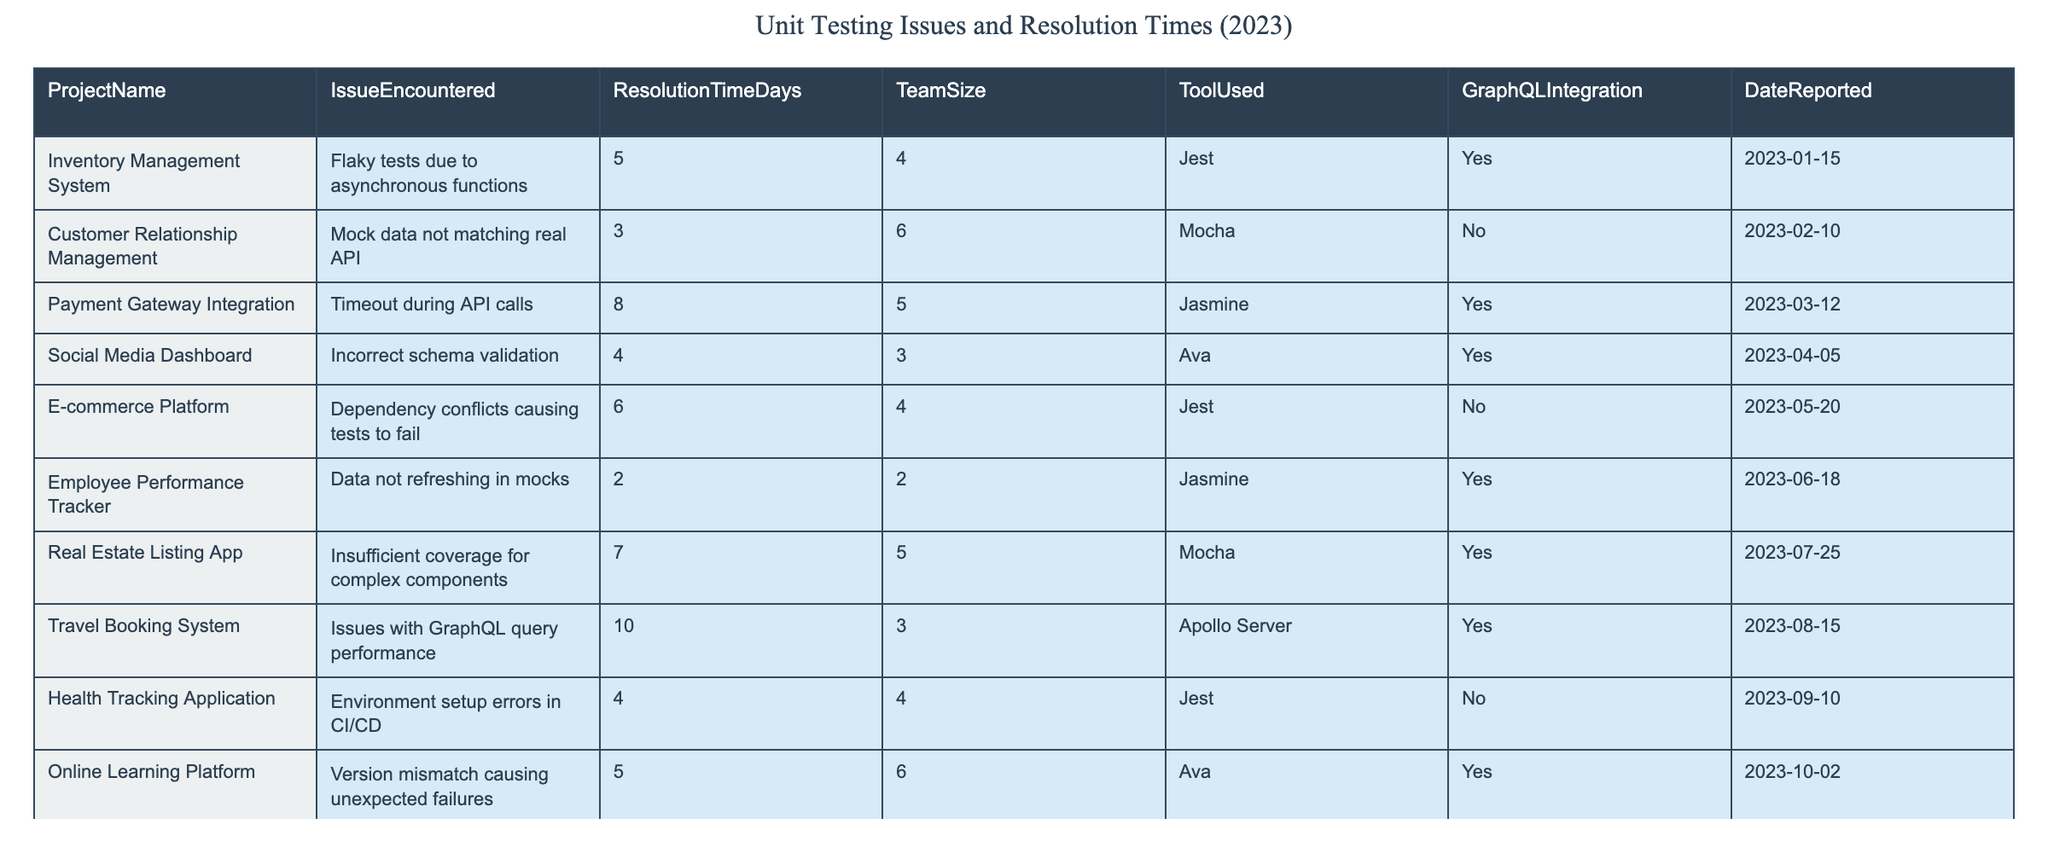What is the longest resolution time encountered in the table? The longest resolution time listed in the table is 10 days, which corresponds to the "Travel Booking System" with an issue related to GraphQL query performance.
Answer: 10 days Which project faced an issue with mocking data and how long did it take to resolve? The "Customer Relationship Management" project faced the issue of mock data not matching the real API, and it took 3 days to resolve.
Answer: Customer Relationship Management, 3 days What percentage of the projects used GraphQL integration? Out of the 10 projects, 6 utilized GraphQL integration. To find the percentage, (6/10) * 100 = 60%.
Answer: 60% Which project had the shortest resolution time and what was the issue? The "Employee Performance Tracker" project had the shortest resolution time of 2 days due to the issue of data not refreshing in mocks.
Answer: Employee Performance Tracker, 2 days Did any projects report environment setup errors? Yes, the "Health Tracking Application" reported environment setup errors in CI/CD.
Answer: Yes How many projects experienced issues with their test tools? Three projects had issues with their testing tools: "Customer Relationship Management," "Payment Gateway Integration," and "E-commerce Platform."
Answer: 3 projects What is the average resolution time for projects that integrated GraphQL? The projects using GraphQL had resolution times of 5, 8, 4, 10, and 5 days. When summed, the total is 32 days, and dividing by 5 projects gives an average of 6.4 days.
Answer: 6.4 days Which issue resolution took the longest time without GraphQL integration? The issue resolution that took the longest without GraphQL integration was for the "E-commerce Platform," which took 6 days due to dependency conflicts causing tests to fail.
Answer: E-commerce Platform, 6 days How many issues were resolved in less than 5 days? There were 4 issues resolved in less than 5 days: "Mock data not matching real API" (3 days), "Data not refreshing in mocks" (2 days), and "Incorrect schema validation" (4 days).
Answer: 4 issues 